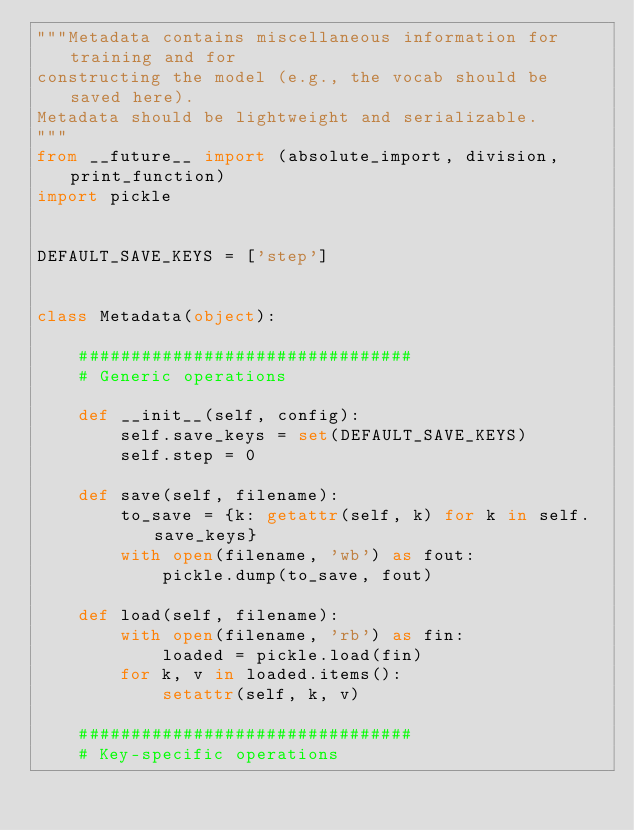<code> <loc_0><loc_0><loc_500><loc_500><_Python_>"""Metadata contains miscellaneous information for training and for
constructing the model (e.g., the vocab should be saved here).
Metadata should be lightweight and serializable.
"""
from __future__ import (absolute_import, division, print_function)
import pickle


DEFAULT_SAVE_KEYS = ['step']


class Metadata(object):

    ################################
    # Generic operations
    
    def __init__(self, config):
        self.save_keys = set(DEFAULT_SAVE_KEYS)
        self.step = 0

    def save(self, filename):
        to_save = {k: getattr(self, k) for k in self.save_keys}
        with open(filename, 'wb') as fout:
            pickle.dump(to_save, fout)

    def load(self, filename):
        with open(filename, 'rb') as fin:
            loaded = pickle.load(fin)
        for k, v in loaded.items():
            setattr(self, k, v)

    ################################
    # Key-specific operations

</code> 